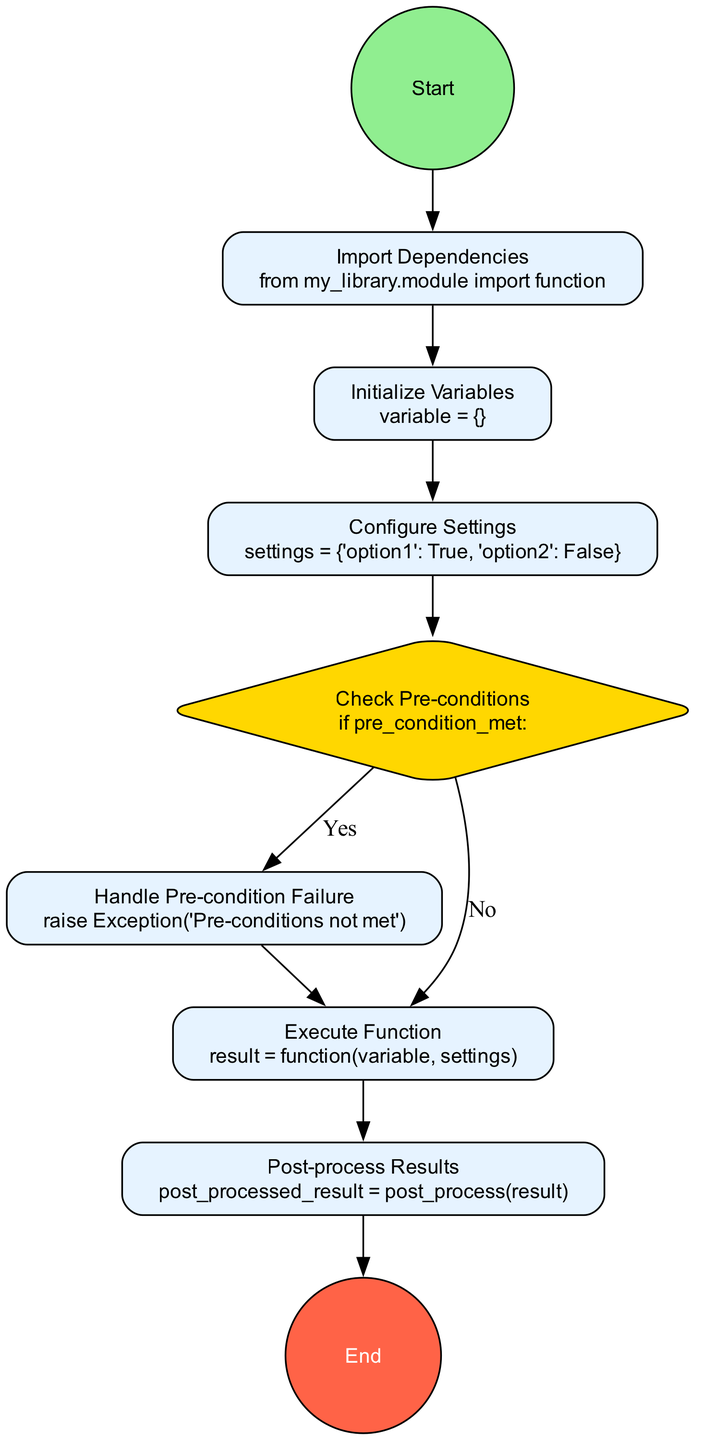What is the first step in the diagram? The first step is indicated by the "Start" node, which signifies the beginning of the process.
Answer: Start How many decision nodes are in the diagram? There is only one decision node in the diagram, which is labeled "Check Pre-conditions."
Answer: 1 What happens if the pre-condition is not met? If the pre-condition is not met, the diagram directs to a node that handles the failure by raising an exception, which is labeled "Handle Pre-condition Failure."
Answer: Raise Exception What is the last step in the diagram? The last step in the diagram is the "End" node, marking the conclusion of the process.
Answer: End Which activity occurs after "Configure Settings"? The activity that occurs after "Configure Settings" is "Check Pre-conditions."
Answer: Check Pre-conditions What are the settings configured in the process? The settings configured are represented in the node labeled "Configure Settings" as "settings = {'option1': True, 'option2': False}."
Answer: settings = {'option1': True, 'option2': False} What action does the diagram take after executing the function? After executing the function, the next action is "Post-process Results," where it handles the result of the function.
Answer: Post-process Results How does the diagram handle a successful pre-condition check? If the pre-condition is met, the flow moves forward to execute the function, as directed from the decision node "Check Pre-conditions."
Answer: Execute Function What function is imported in the initialization process? The function imported in the process is specified in the "Import Dependencies" node as "function."
Answer: function 